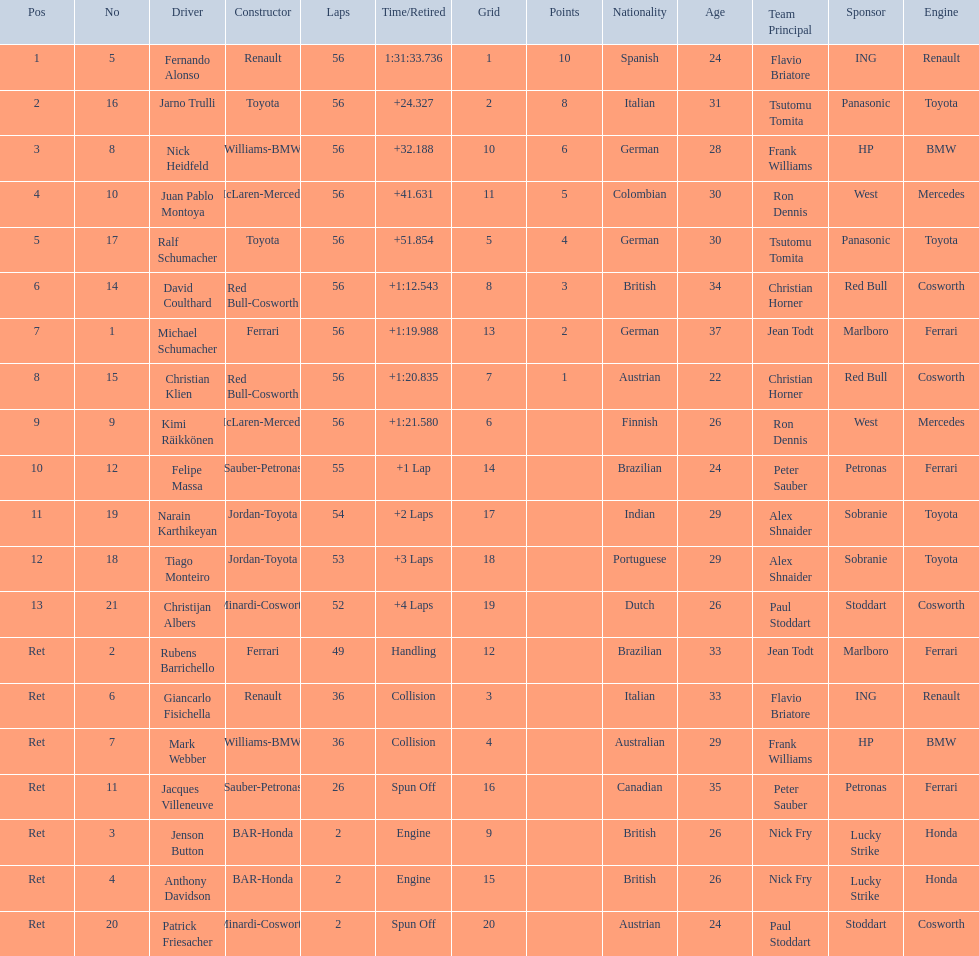Who was fernando alonso's instructor? Renault. How many laps did fernando alonso run? 56. How long did it take alonso to complete the race? 1:31:33.736. 